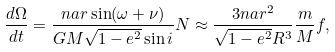Convert formula to latex. <formula><loc_0><loc_0><loc_500><loc_500>\frac { d \Omega } { d t } = \frac { n a r \sin ( \omega + \nu ) } { G M \sqrt { 1 - e ^ { 2 } } \sin i } N \approx \frac { 3 n a r ^ { 2 } } { \sqrt { 1 - e ^ { 2 } } R ^ { 3 } } \frac { m } { M } f ,</formula> 